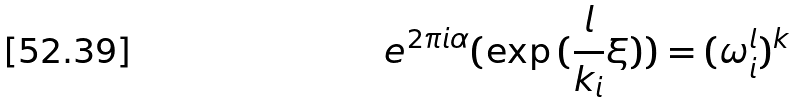Convert formula to latex. <formula><loc_0><loc_0><loc_500><loc_500>e ^ { 2 \pi i \alpha } ( \exp { ( \frac { l } { k _ { i } } \xi ) } ) = ( \omega _ { i } ^ { l } ) ^ { k }</formula> 